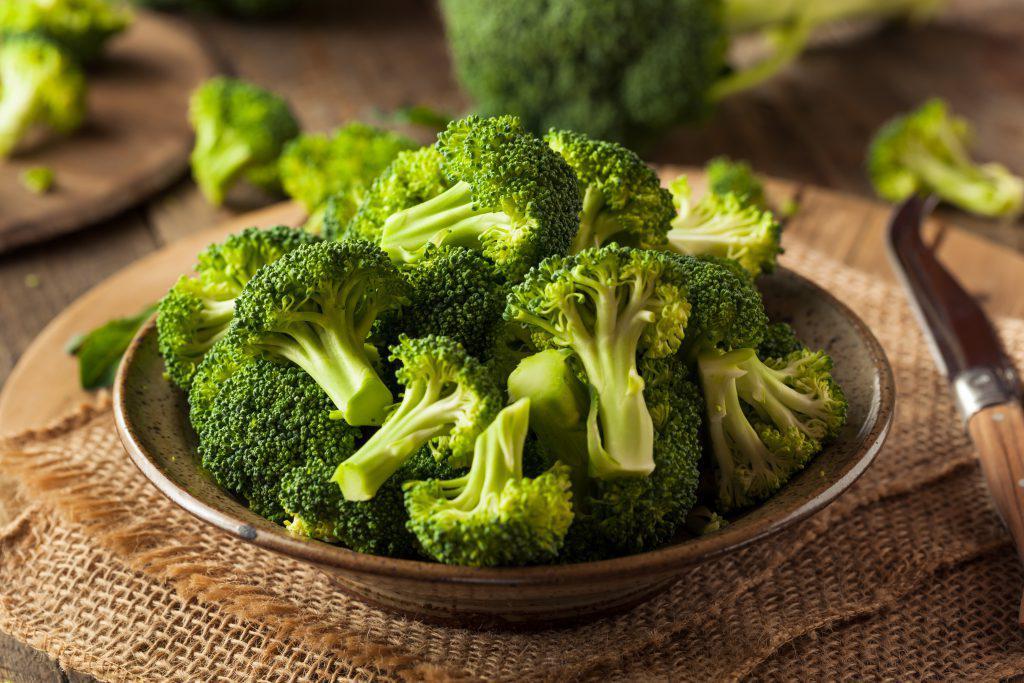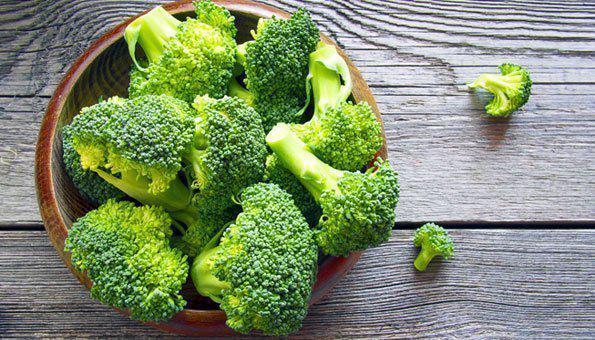The first image is the image on the left, the second image is the image on the right. Evaluate the accuracy of this statement regarding the images: "There is exactly one bowl of broccoli.". Is it true? Answer yes or no. No. The first image is the image on the left, the second image is the image on the right. For the images shown, is this caption "A bowl of just broccoli sits on a table with some broccoli pieces around it." true? Answer yes or no. Yes. 